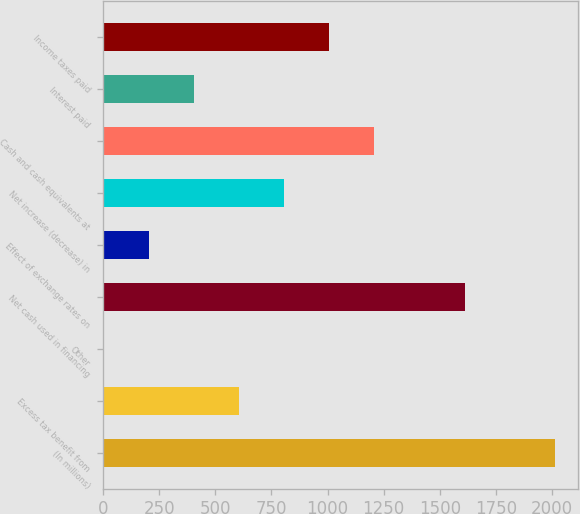<chart> <loc_0><loc_0><loc_500><loc_500><bar_chart><fcel>(In millions)<fcel>Excess tax benefit from<fcel>Other<fcel>Net cash used in financing<fcel>Effect of exchange rates on<fcel>Net increase (decrease) in<fcel>Cash and cash equivalents at<fcel>Interest paid<fcel>Income taxes paid<nl><fcel>2014<fcel>604.9<fcel>1<fcel>1611.4<fcel>202.3<fcel>806.2<fcel>1208.8<fcel>403.6<fcel>1007.5<nl></chart> 